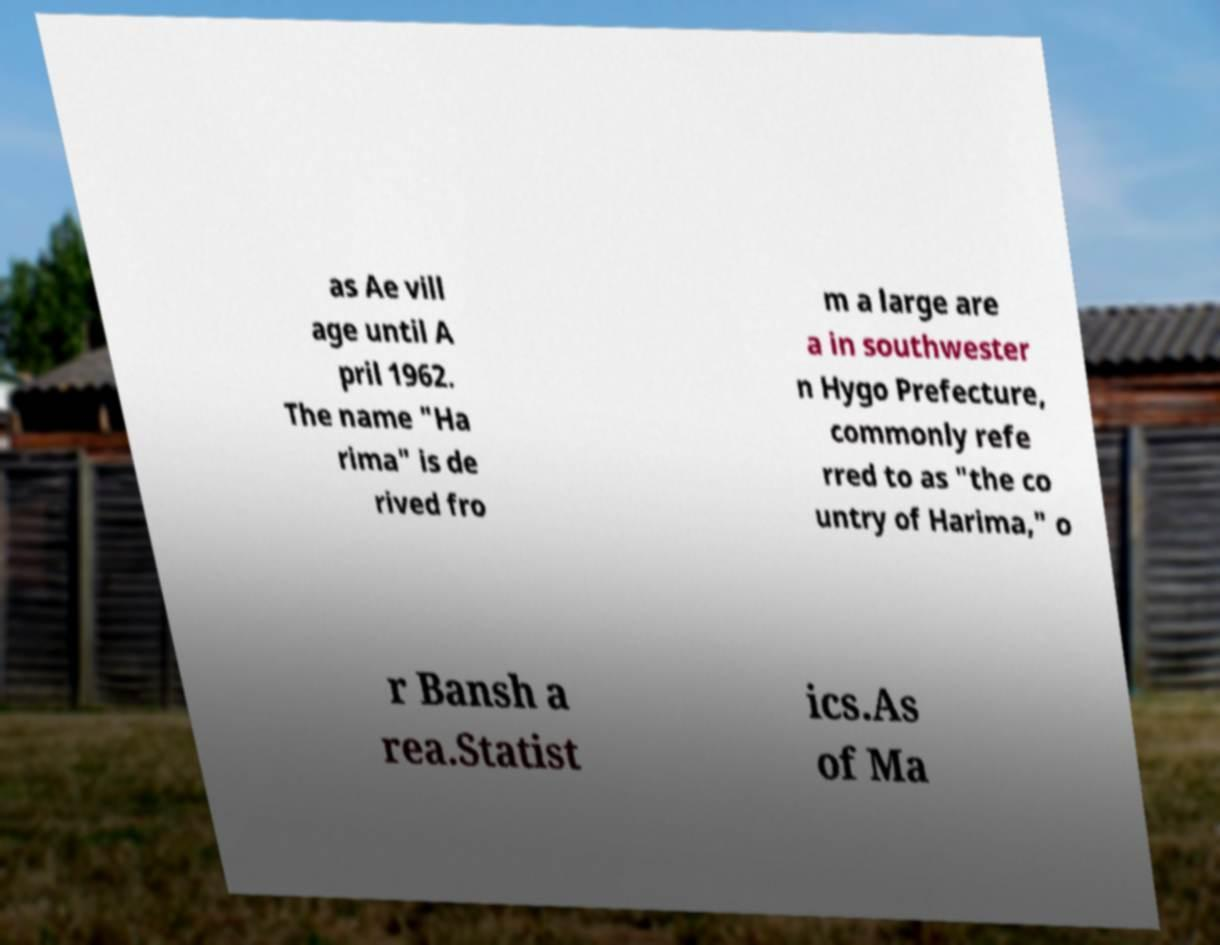Could you assist in decoding the text presented in this image and type it out clearly? as Ae vill age until A pril 1962. The name "Ha rima" is de rived fro m a large are a in southwester n Hygo Prefecture, commonly refe rred to as "the co untry of Harima," o r Bansh a rea.Statist ics.As of Ma 